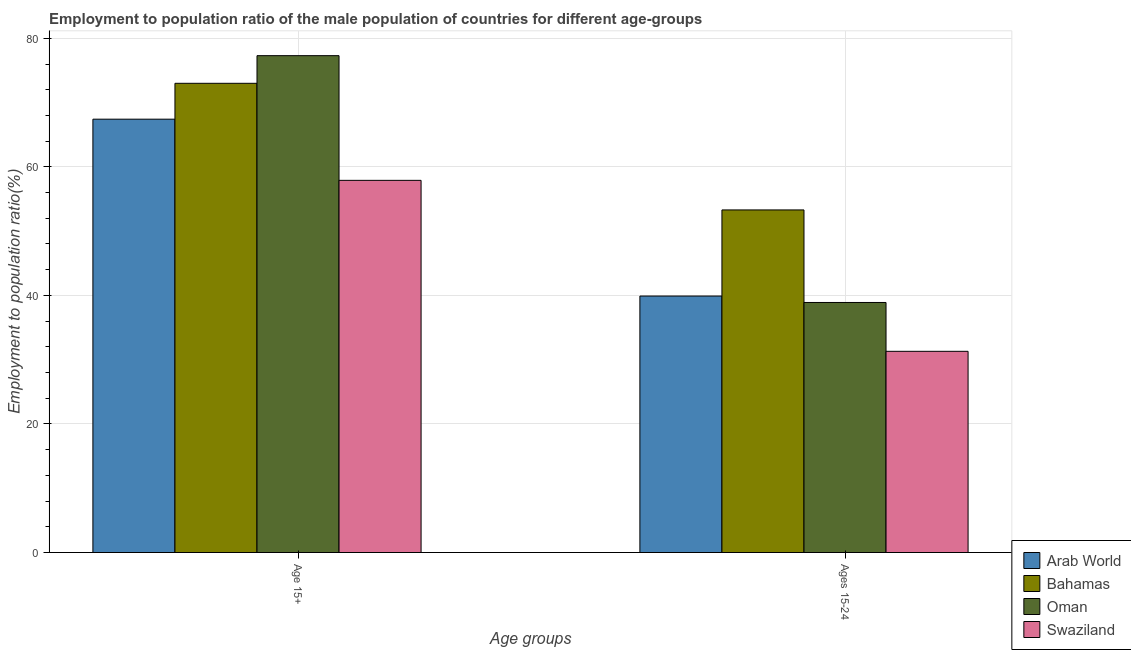How many different coloured bars are there?
Your response must be concise. 4. Are the number of bars on each tick of the X-axis equal?
Your answer should be compact. Yes. How many bars are there on the 2nd tick from the left?
Provide a short and direct response. 4. How many bars are there on the 1st tick from the right?
Your response must be concise. 4. What is the label of the 2nd group of bars from the left?
Make the answer very short. Ages 15-24. What is the employment to population ratio(age 15+) in Swaziland?
Ensure brevity in your answer.  57.9. Across all countries, what is the maximum employment to population ratio(age 15-24)?
Offer a terse response. 53.3. Across all countries, what is the minimum employment to population ratio(age 15-24)?
Your response must be concise. 31.3. In which country was the employment to population ratio(age 15-24) maximum?
Your answer should be compact. Bahamas. In which country was the employment to population ratio(age 15+) minimum?
Offer a terse response. Swaziland. What is the total employment to population ratio(age 15-24) in the graph?
Ensure brevity in your answer.  163.4. What is the difference between the employment to population ratio(age 15-24) in Bahamas and that in Swaziland?
Give a very brief answer. 22. What is the difference between the employment to population ratio(age 15+) in Swaziland and the employment to population ratio(age 15-24) in Arab World?
Keep it short and to the point. 18. What is the average employment to population ratio(age 15-24) per country?
Provide a short and direct response. 40.85. What is the difference between the employment to population ratio(age 15+) and employment to population ratio(age 15-24) in Oman?
Offer a very short reply. 38.4. In how many countries, is the employment to population ratio(age 15+) greater than 8 %?
Offer a very short reply. 4. What is the ratio of the employment to population ratio(age 15-24) in Bahamas to that in Swaziland?
Your answer should be compact. 1.7. What does the 4th bar from the left in Age 15+ represents?
Offer a terse response. Swaziland. What does the 3rd bar from the right in Age 15+ represents?
Offer a terse response. Bahamas. How many bars are there?
Keep it short and to the point. 8. How many countries are there in the graph?
Give a very brief answer. 4. Are the values on the major ticks of Y-axis written in scientific E-notation?
Your answer should be compact. No. Does the graph contain any zero values?
Offer a terse response. No. Does the graph contain grids?
Ensure brevity in your answer.  Yes. What is the title of the graph?
Give a very brief answer. Employment to population ratio of the male population of countries for different age-groups. Does "Egypt, Arab Rep." appear as one of the legend labels in the graph?
Provide a short and direct response. No. What is the label or title of the X-axis?
Keep it short and to the point. Age groups. What is the label or title of the Y-axis?
Offer a very short reply. Employment to population ratio(%). What is the Employment to population ratio(%) of Arab World in Age 15+?
Provide a succinct answer. 67.42. What is the Employment to population ratio(%) of Oman in Age 15+?
Give a very brief answer. 77.3. What is the Employment to population ratio(%) of Swaziland in Age 15+?
Offer a terse response. 57.9. What is the Employment to population ratio(%) of Arab World in Ages 15-24?
Make the answer very short. 39.9. What is the Employment to population ratio(%) in Bahamas in Ages 15-24?
Your answer should be very brief. 53.3. What is the Employment to population ratio(%) of Oman in Ages 15-24?
Make the answer very short. 38.9. What is the Employment to population ratio(%) in Swaziland in Ages 15-24?
Offer a very short reply. 31.3. Across all Age groups, what is the maximum Employment to population ratio(%) in Arab World?
Your answer should be compact. 67.42. Across all Age groups, what is the maximum Employment to population ratio(%) in Bahamas?
Offer a terse response. 73. Across all Age groups, what is the maximum Employment to population ratio(%) of Oman?
Give a very brief answer. 77.3. Across all Age groups, what is the maximum Employment to population ratio(%) in Swaziland?
Your answer should be very brief. 57.9. Across all Age groups, what is the minimum Employment to population ratio(%) of Arab World?
Your response must be concise. 39.9. Across all Age groups, what is the minimum Employment to population ratio(%) of Bahamas?
Make the answer very short. 53.3. Across all Age groups, what is the minimum Employment to population ratio(%) in Oman?
Give a very brief answer. 38.9. Across all Age groups, what is the minimum Employment to population ratio(%) in Swaziland?
Keep it short and to the point. 31.3. What is the total Employment to population ratio(%) of Arab World in the graph?
Your response must be concise. 107.32. What is the total Employment to population ratio(%) of Bahamas in the graph?
Make the answer very short. 126.3. What is the total Employment to population ratio(%) in Oman in the graph?
Offer a very short reply. 116.2. What is the total Employment to population ratio(%) of Swaziland in the graph?
Give a very brief answer. 89.2. What is the difference between the Employment to population ratio(%) in Arab World in Age 15+ and that in Ages 15-24?
Your answer should be very brief. 27.52. What is the difference between the Employment to population ratio(%) in Bahamas in Age 15+ and that in Ages 15-24?
Offer a terse response. 19.7. What is the difference between the Employment to population ratio(%) of Oman in Age 15+ and that in Ages 15-24?
Give a very brief answer. 38.4. What is the difference between the Employment to population ratio(%) in Swaziland in Age 15+ and that in Ages 15-24?
Offer a very short reply. 26.6. What is the difference between the Employment to population ratio(%) of Arab World in Age 15+ and the Employment to population ratio(%) of Bahamas in Ages 15-24?
Offer a very short reply. 14.12. What is the difference between the Employment to population ratio(%) in Arab World in Age 15+ and the Employment to population ratio(%) in Oman in Ages 15-24?
Offer a very short reply. 28.52. What is the difference between the Employment to population ratio(%) in Arab World in Age 15+ and the Employment to population ratio(%) in Swaziland in Ages 15-24?
Provide a succinct answer. 36.12. What is the difference between the Employment to population ratio(%) of Bahamas in Age 15+ and the Employment to population ratio(%) of Oman in Ages 15-24?
Offer a terse response. 34.1. What is the difference between the Employment to population ratio(%) of Bahamas in Age 15+ and the Employment to population ratio(%) of Swaziland in Ages 15-24?
Offer a very short reply. 41.7. What is the average Employment to population ratio(%) of Arab World per Age groups?
Provide a short and direct response. 53.66. What is the average Employment to population ratio(%) in Bahamas per Age groups?
Your answer should be compact. 63.15. What is the average Employment to population ratio(%) of Oman per Age groups?
Provide a succinct answer. 58.1. What is the average Employment to population ratio(%) in Swaziland per Age groups?
Give a very brief answer. 44.6. What is the difference between the Employment to population ratio(%) in Arab World and Employment to population ratio(%) in Bahamas in Age 15+?
Give a very brief answer. -5.58. What is the difference between the Employment to population ratio(%) in Arab World and Employment to population ratio(%) in Oman in Age 15+?
Your answer should be very brief. -9.88. What is the difference between the Employment to population ratio(%) in Arab World and Employment to population ratio(%) in Swaziland in Age 15+?
Ensure brevity in your answer.  9.52. What is the difference between the Employment to population ratio(%) of Bahamas and Employment to population ratio(%) of Swaziland in Age 15+?
Your answer should be very brief. 15.1. What is the difference between the Employment to population ratio(%) in Oman and Employment to population ratio(%) in Swaziland in Age 15+?
Ensure brevity in your answer.  19.4. What is the difference between the Employment to population ratio(%) in Arab World and Employment to population ratio(%) in Bahamas in Ages 15-24?
Offer a terse response. -13.4. What is the difference between the Employment to population ratio(%) in Arab World and Employment to population ratio(%) in Oman in Ages 15-24?
Ensure brevity in your answer.  1. What is the difference between the Employment to population ratio(%) in Arab World and Employment to population ratio(%) in Swaziland in Ages 15-24?
Give a very brief answer. 8.6. What is the difference between the Employment to population ratio(%) in Oman and Employment to population ratio(%) in Swaziland in Ages 15-24?
Make the answer very short. 7.6. What is the ratio of the Employment to population ratio(%) in Arab World in Age 15+ to that in Ages 15-24?
Offer a terse response. 1.69. What is the ratio of the Employment to population ratio(%) of Bahamas in Age 15+ to that in Ages 15-24?
Ensure brevity in your answer.  1.37. What is the ratio of the Employment to population ratio(%) of Oman in Age 15+ to that in Ages 15-24?
Keep it short and to the point. 1.99. What is the ratio of the Employment to population ratio(%) in Swaziland in Age 15+ to that in Ages 15-24?
Offer a terse response. 1.85. What is the difference between the highest and the second highest Employment to population ratio(%) of Arab World?
Give a very brief answer. 27.52. What is the difference between the highest and the second highest Employment to population ratio(%) of Bahamas?
Your response must be concise. 19.7. What is the difference between the highest and the second highest Employment to population ratio(%) in Oman?
Offer a very short reply. 38.4. What is the difference between the highest and the second highest Employment to population ratio(%) in Swaziland?
Make the answer very short. 26.6. What is the difference between the highest and the lowest Employment to population ratio(%) of Arab World?
Provide a short and direct response. 27.52. What is the difference between the highest and the lowest Employment to population ratio(%) of Oman?
Provide a short and direct response. 38.4. What is the difference between the highest and the lowest Employment to population ratio(%) in Swaziland?
Provide a short and direct response. 26.6. 